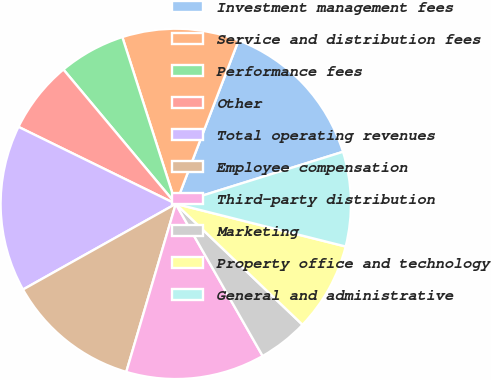<chart> <loc_0><loc_0><loc_500><loc_500><pie_chart><fcel>Investment management fees<fcel>Service and distribution fees<fcel>Performance fees<fcel>Other<fcel>Total operating revenues<fcel>Employee compensation<fcel>Third-party distribution<fcel>Marketing<fcel>Property office and technology<fcel>General and administrative<nl><fcel>14.36%<fcel>10.77%<fcel>6.15%<fcel>6.67%<fcel>15.38%<fcel>12.31%<fcel>12.82%<fcel>4.62%<fcel>8.21%<fcel>8.72%<nl></chart> 